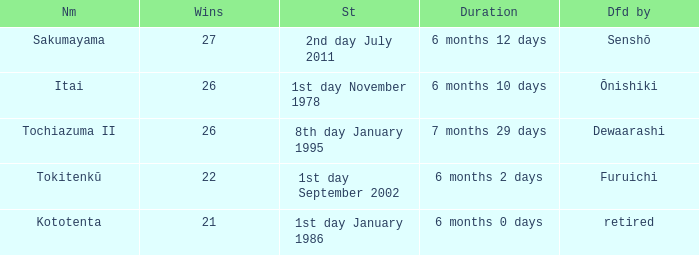How many wins, on average, were defeated by furuichi? 22.0. 